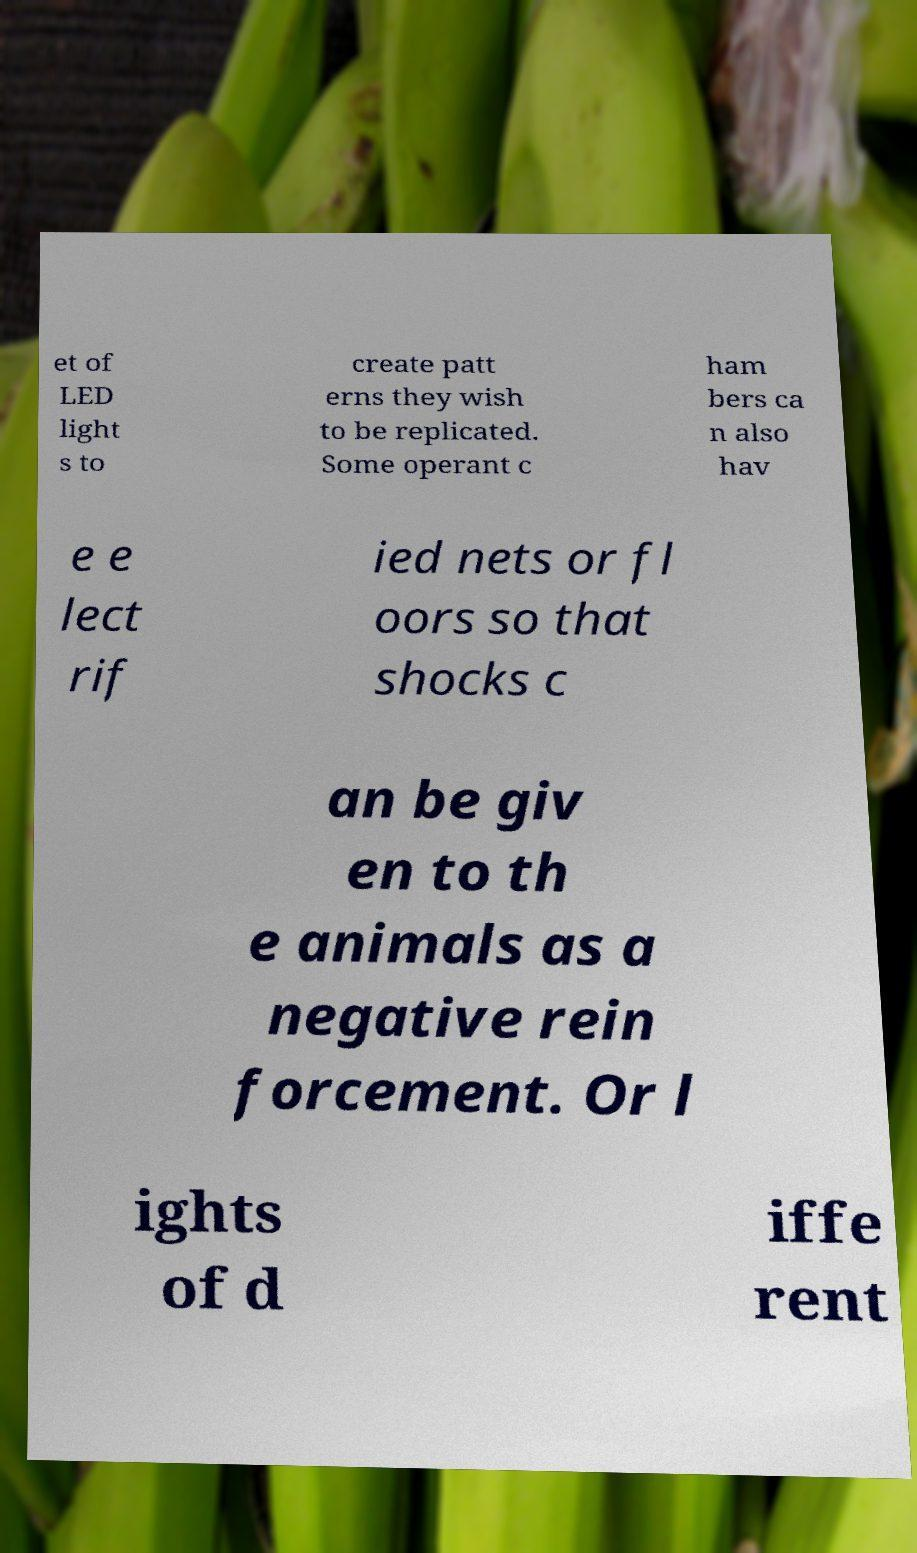There's text embedded in this image that I need extracted. Can you transcribe it verbatim? et of LED light s to create patt erns they wish to be replicated. Some operant c ham bers ca n also hav e e lect rif ied nets or fl oors so that shocks c an be giv en to th e animals as a negative rein forcement. Or l ights of d iffe rent 